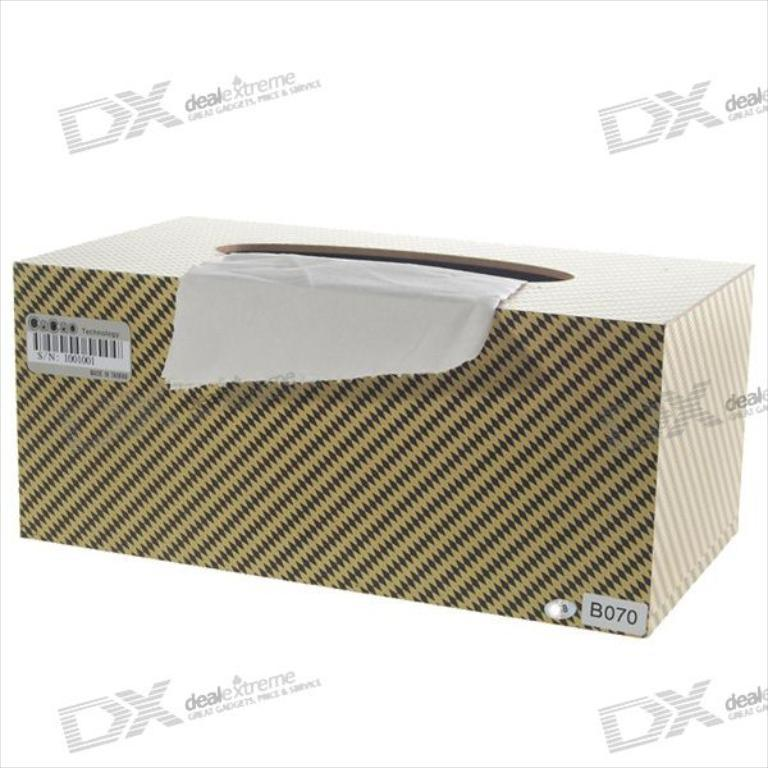<image>
Summarize the visual content of the image. A box with paper towel in it and a background of word that says deal extreme. 